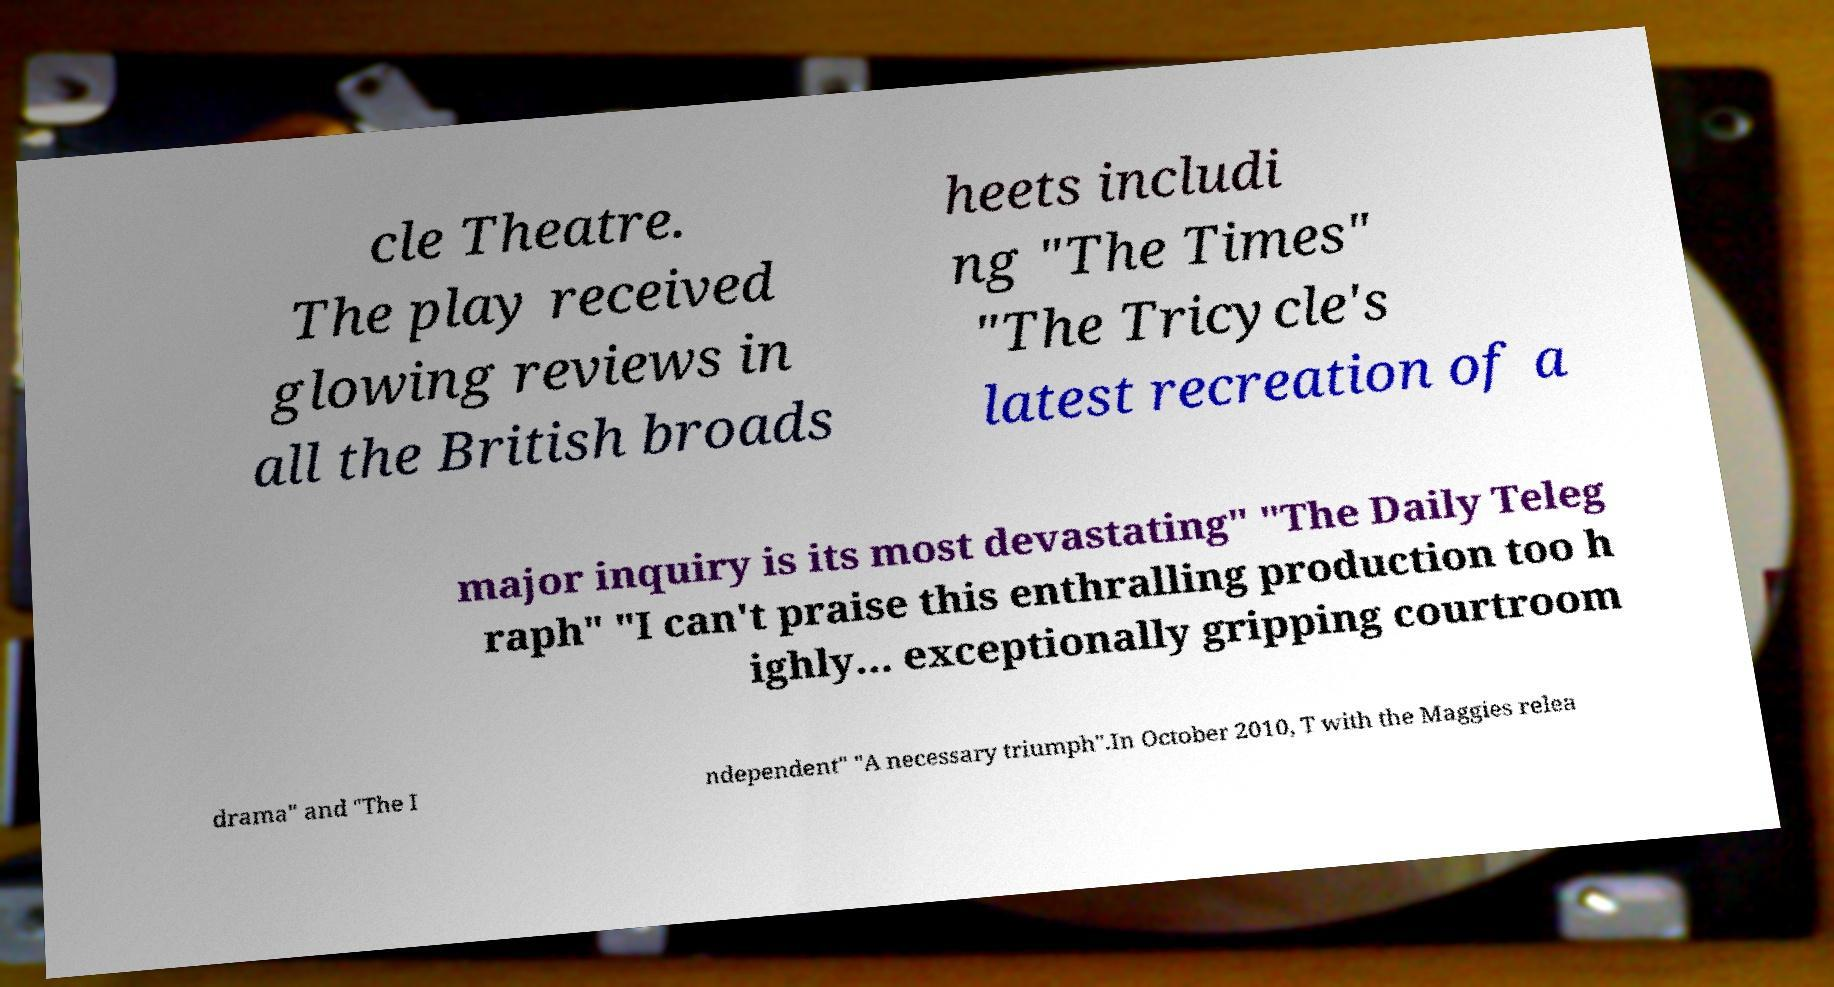Please identify and transcribe the text found in this image. cle Theatre. The play received glowing reviews in all the British broads heets includi ng "The Times" "The Tricycle's latest recreation of a major inquiry is its most devastating" "The Daily Teleg raph" "I can't praise this enthralling production too h ighly… exceptionally gripping courtroom drama" and "The I ndependent" "A necessary triumph".In October 2010, T with the Maggies relea 